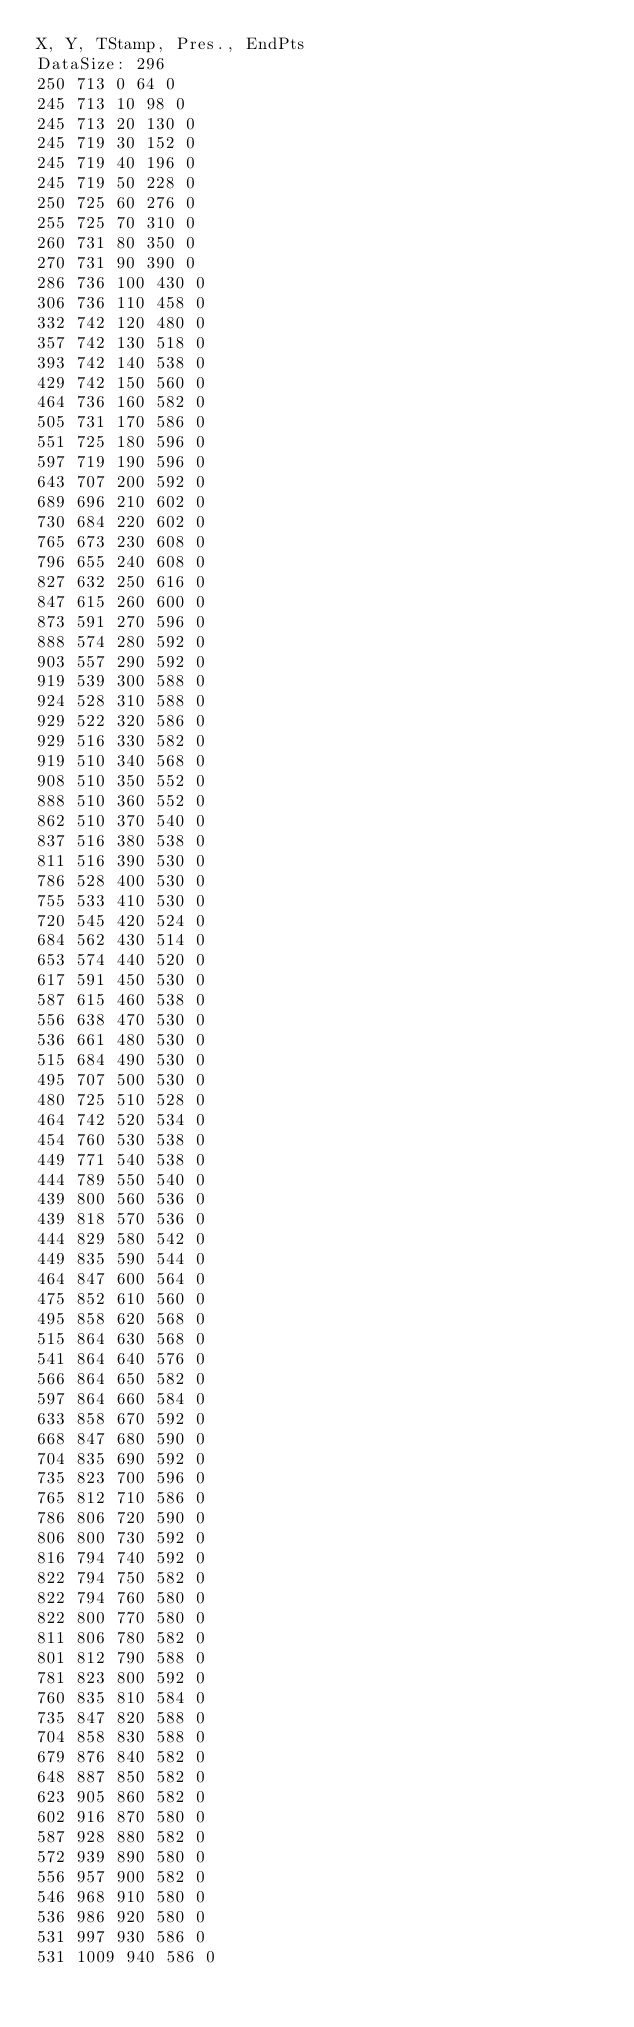<code> <loc_0><loc_0><loc_500><loc_500><_SML_>X, Y, TStamp, Pres., EndPts
DataSize: 296
250 713 0 64 0
245 713 10 98 0
245 713 20 130 0
245 719 30 152 0
245 719 40 196 0
245 719 50 228 0
250 725 60 276 0
255 725 70 310 0
260 731 80 350 0
270 731 90 390 0
286 736 100 430 0
306 736 110 458 0
332 742 120 480 0
357 742 130 518 0
393 742 140 538 0
429 742 150 560 0
464 736 160 582 0
505 731 170 586 0
551 725 180 596 0
597 719 190 596 0
643 707 200 592 0
689 696 210 602 0
730 684 220 602 0
765 673 230 608 0
796 655 240 608 0
827 632 250 616 0
847 615 260 600 0
873 591 270 596 0
888 574 280 592 0
903 557 290 592 0
919 539 300 588 0
924 528 310 588 0
929 522 320 586 0
929 516 330 582 0
919 510 340 568 0
908 510 350 552 0
888 510 360 552 0
862 510 370 540 0
837 516 380 538 0
811 516 390 530 0
786 528 400 530 0
755 533 410 530 0
720 545 420 524 0
684 562 430 514 0
653 574 440 520 0
617 591 450 530 0
587 615 460 538 0
556 638 470 530 0
536 661 480 530 0
515 684 490 530 0
495 707 500 530 0
480 725 510 528 0
464 742 520 534 0
454 760 530 538 0
449 771 540 538 0
444 789 550 540 0
439 800 560 536 0
439 818 570 536 0
444 829 580 542 0
449 835 590 544 0
464 847 600 564 0
475 852 610 560 0
495 858 620 568 0
515 864 630 568 0
541 864 640 576 0
566 864 650 582 0
597 864 660 584 0
633 858 670 592 0
668 847 680 590 0
704 835 690 592 0
735 823 700 596 0
765 812 710 586 0
786 806 720 590 0
806 800 730 592 0
816 794 740 592 0
822 794 750 582 0
822 794 760 580 0
822 800 770 580 0
811 806 780 582 0
801 812 790 588 0
781 823 800 592 0
760 835 810 584 0
735 847 820 588 0
704 858 830 588 0
679 876 840 582 0
648 887 850 582 0
623 905 860 582 0
602 916 870 580 0
587 928 880 582 0
572 939 890 580 0
556 957 900 582 0
546 968 910 580 0
536 986 920 580 0
531 997 930 586 0
531 1009 940 586 0</code> 